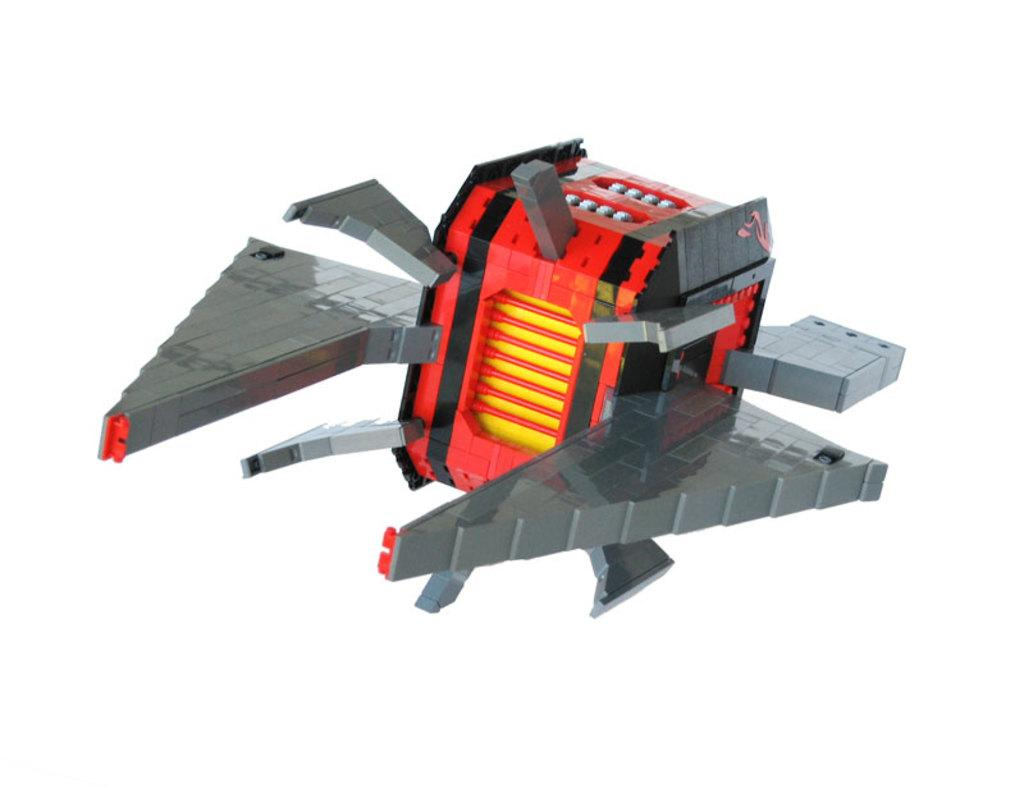What object can be seen in the image? There is a toy in the image. What color is the background of the image? The background of the image is white. What type of throne is depicted in the image? There is no throne present in the image; it features a toy and a white background. 